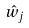Convert formula to latex. <formula><loc_0><loc_0><loc_500><loc_500>\hat { w } _ { j }</formula> 